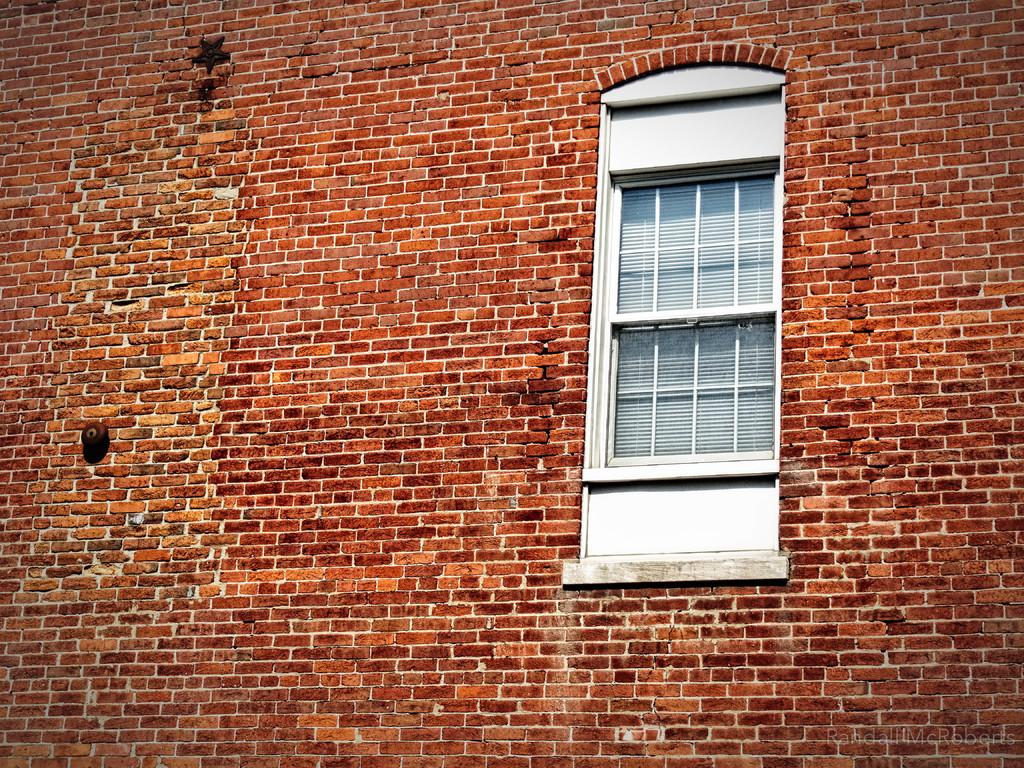What is located in the center of the image? There are windows in the center of the image. What type of window treatment is present in the image? Window blinds are present in the image. What type of wall can be seen in the image? There is a brick wall visible in the image. What type of nut is used to hold the window blinds in place in the image? There is no mention of nuts in the image, and the window blinds are not described as being held in place by any specific type of fastener. 